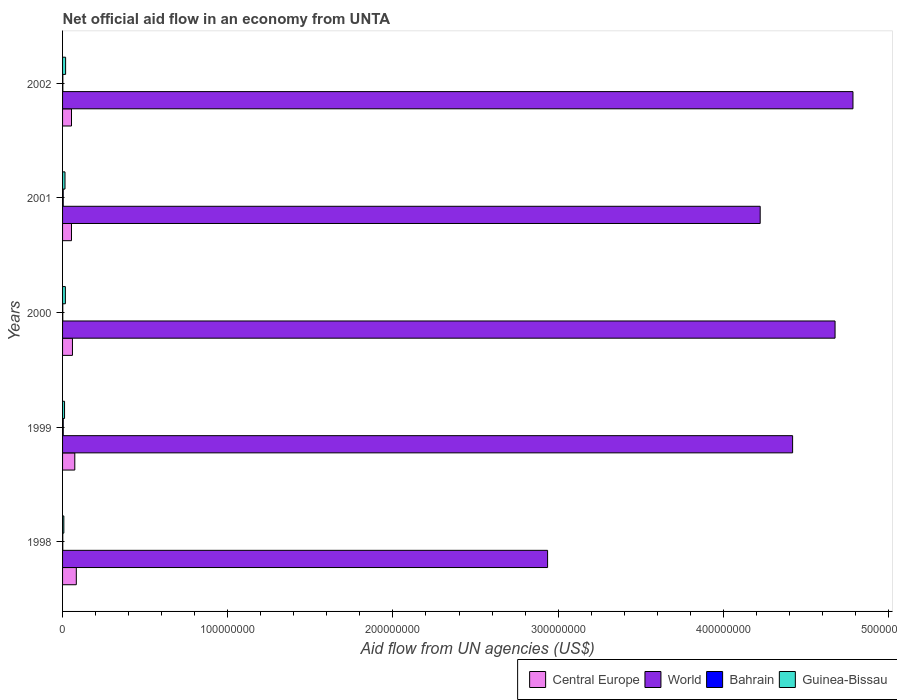How many groups of bars are there?
Provide a short and direct response. 5. Are the number of bars per tick equal to the number of legend labels?
Your answer should be compact. Yes. How many bars are there on the 1st tick from the top?
Provide a succinct answer. 4. What is the label of the 5th group of bars from the top?
Offer a terse response. 1998. What is the net official aid flow in Guinea-Bissau in 1998?
Your answer should be compact. 7.70e+05. Across all years, what is the maximum net official aid flow in Bahrain?
Ensure brevity in your answer.  4.00e+05. Across all years, what is the minimum net official aid flow in Central Europe?
Your answer should be compact. 5.40e+06. In which year was the net official aid flow in World maximum?
Offer a terse response. 2002. In which year was the net official aid flow in Guinea-Bissau minimum?
Offer a very short reply. 1998. What is the total net official aid flow in Guinea-Bissau in the graph?
Offer a terse response. 6.98e+06. What is the difference between the net official aid flow in Central Europe in 1998 and that in 1999?
Keep it short and to the point. 9.20e+05. What is the difference between the net official aid flow in Guinea-Bissau in 1999 and the net official aid flow in World in 2002?
Provide a short and direct response. -4.77e+08. What is the average net official aid flow in World per year?
Give a very brief answer. 4.21e+08. In the year 2002, what is the difference between the net official aid flow in World and net official aid flow in Bahrain?
Offer a terse response. 4.78e+08. What is the ratio of the net official aid flow in World in 1999 to that in 2000?
Your answer should be very brief. 0.95. Is the net official aid flow in Central Europe in 1999 less than that in 2002?
Your response must be concise. No. What is the difference between the highest and the second highest net official aid flow in Central Europe?
Ensure brevity in your answer.  9.20e+05. What is the difference between the highest and the lowest net official aid flow in Central Europe?
Make the answer very short. 2.92e+06. What does the 2nd bar from the top in 2001 represents?
Provide a succinct answer. Bahrain. How many bars are there?
Offer a terse response. 20. Are all the bars in the graph horizontal?
Make the answer very short. Yes. What is the difference between two consecutive major ticks on the X-axis?
Make the answer very short. 1.00e+08. How many legend labels are there?
Provide a succinct answer. 4. How are the legend labels stacked?
Make the answer very short. Horizontal. What is the title of the graph?
Provide a short and direct response. Net official aid flow in an economy from UNTA. What is the label or title of the X-axis?
Give a very brief answer. Aid flow from UN agencies (US$). What is the Aid flow from UN agencies (US$) of Central Europe in 1998?
Ensure brevity in your answer.  8.32e+06. What is the Aid flow from UN agencies (US$) of World in 1998?
Make the answer very short. 2.94e+08. What is the Aid flow from UN agencies (US$) in Bahrain in 1998?
Your answer should be very brief. 1.30e+05. What is the Aid flow from UN agencies (US$) in Guinea-Bissau in 1998?
Keep it short and to the point. 7.70e+05. What is the Aid flow from UN agencies (US$) of Central Europe in 1999?
Your answer should be very brief. 7.40e+06. What is the Aid flow from UN agencies (US$) in World in 1999?
Your answer should be very brief. 4.42e+08. What is the Aid flow from UN agencies (US$) of Guinea-Bissau in 1999?
Give a very brief answer. 1.20e+06. What is the Aid flow from UN agencies (US$) of Central Europe in 2000?
Make the answer very short. 5.99e+06. What is the Aid flow from UN agencies (US$) in World in 2000?
Give a very brief answer. 4.68e+08. What is the Aid flow from UN agencies (US$) of Guinea-Bissau in 2000?
Your answer should be compact. 1.70e+06. What is the Aid flow from UN agencies (US$) in Central Europe in 2001?
Offer a terse response. 5.40e+06. What is the Aid flow from UN agencies (US$) in World in 2001?
Give a very brief answer. 4.22e+08. What is the Aid flow from UN agencies (US$) of Bahrain in 2001?
Provide a short and direct response. 3.90e+05. What is the Aid flow from UN agencies (US$) in Guinea-Bissau in 2001?
Keep it short and to the point. 1.47e+06. What is the Aid flow from UN agencies (US$) of Central Europe in 2002?
Offer a very short reply. 5.41e+06. What is the Aid flow from UN agencies (US$) of World in 2002?
Keep it short and to the point. 4.78e+08. What is the Aid flow from UN agencies (US$) in Guinea-Bissau in 2002?
Your answer should be compact. 1.84e+06. Across all years, what is the maximum Aid flow from UN agencies (US$) in Central Europe?
Make the answer very short. 8.32e+06. Across all years, what is the maximum Aid flow from UN agencies (US$) in World?
Make the answer very short. 4.78e+08. Across all years, what is the maximum Aid flow from UN agencies (US$) of Guinea-Bissau?
Make the answer very short. 1.84e+06. Across all years, what is the minimum Aid flow from UN agencies (US$) in Central Europe?
Ensure brevity in your answer.  5.40e+06. Across all years, what is the minimum Aid flow from UN agencies (US$) in World?
Keep it short and to the point. 2.94e+08. Across all years, what is the minimum Aid flow from UN agencies (US$) in Guinea-Bissau?
Ensure brevity in your answer.  7.70e+05. What is the total Aid flow from UN agencies (US$) in Central Europe in the graph?
Provide a short and direct response. 3.25e+07. What is the total Aid flow from UN agencies (US$) in World in the graph?
Offer a terse response. 2.10e+09. What is the total Aid flow from UN agencies (US$) in Bahrain in the graph?
Your answer should be compact. 1.22e+06. What is the total Aid flow from UN agencies (US$) in Guinea-Bissau in the graph?
Your answer should be compact. 6.98e+06. What is the difference between the Aid flow from UN agencies (US$) in Central Europe in 1998 and that in 1999?
Offer a terse response. 9.20e+05. What is the difference between the Aid flow from UN agencies (US$) of World in 1998 and that in 1999?
Your answer should be compact. -1.48e+08. What is the difference between the Aid flow from UN agencies (US$) of Guinea-Bissau in 1998 and that in 1999?
Your answer should be compact. -4.30e+05. What is the difference between the Aid flow from UN agencies (US$) in Central Europe in 1998 and that in 2000?
Offer a terse response. 2.33e+06. What is the difference between the Aid flow from UN agencies (US$) of World in 1998 and that in 2000?
Ensure brevity in your answer.  -1.74e+08. What is the difference between the Aid flow from UN agencies (US$) of Guinea-Bissau in 1998 and that in 2000?
Make the answer very short. -9.30e+05. What is the difference between the Aid flow from UN agencies (US$) in Central Europe in 1998 and that in 2001?
Keep it short and to the point. 2.92e+06. What is the difference between the Aid flow from UN agencies (US$) in World in 1998 and that in 2001?
Offer a terse response. -1.29e+08. What is the difference between the Aid flow from UN agencies (US$) of Bahrain in 1998 and that in 2001?
Offer a very short reply. -2.60e+05. What is the difference between the Aid flow from UN agencies (US$) in Guinea-Bissau in 1998 and that in 2001?
Offer a terse response. -7.00e+05. What is the difference between the Aid flow from UN agencies (US$) in Central Europe in 1998 and that in 2002?
Provide a succinct answer. 2.91e+06. What is the difference between the Aid flow from UN agencies (US$) in World in 1998 and that in 2002?
Your response must be concise. -1.85e+08. What is the difference between the Aid flow from UN agencies (US$) of Guinea-Bissau in 1998 and that in 2002?
Ensure brevity in your answer.  -1.07e+06. What is the difference between the Aid flow from UN agencies (US$) in Central Europe in 1999 and that in 2000?
Offer a very short reply. 1.41e+06. What is the difference between the Aid flow from UN agencies (US$) of World in 1999 and that in 2000?
Make the answer very short. -2.57e+07. What is the difference between the Aid flow from UN agencies (US$) of Bahrain in 1999 and that in 2000?
Your response must be concise. 2.70e+05. What is the difference between the Aid flow from UN agencies (US$) of Guinea-Bissau in 1999 and that in 2000?
Provide a short and direct response. -5.00e+05. What is the difference between the Aid flow from UN agencies (US$) of Central Europe in 1999 and that in 2001?
Your response must be concise. 2.00e+06. What is the difference between the Aid flow from UN agencies (US$) in World in 1999 and that in 2001?
Your answer should be compact. 1.96e+07. What is the difference between the Aid flow from UN agencies (US$) in Bahrain in 1999 and that in 2001?
Offer a terse response. 10000. What is the difference between the Aid flow from UN agencies (US$) in Guinea-Bissau in 1999 and that in 2001?
Ensure brevity in your answer.  -2.70e+05. What is the difference between the Aid flow from UN agencies (US$) in Central Europe in 1999 and that in 2002?
Your answer should be compact. 1.99e+06. What is the difference between the Aid flow from UN agencies (US$) in World in 1999 and that in 2002?
Offer a very short reply. -3.65e+07. What is the difference between the Aid flow from UN agencies (US$) of Guinea-Bissau in 1999 and that in 2002?
Give a very brief answer. -6.40e+05. What is the difference between the Aid flow from UN agencies (US$) in Central Europe in 2000 and that in 2001?
Offer a very short reply. 5.90e+05. What is the difference between the Aid flow from UN agencies (US$) in World in 2000 and that in 2001?
Offer a very short reply. 4.53e+07. What is the difference between the Aid flow from UN agencies (US$) of Bahrain in 2000 and that in 2001?
Your response must be concise. -2.60e+05. What is the difference between the Aid flow from UN agencies (US$) in Guinea-Bissau in 2000 and that in 2001?
Give a very brief answer. 2.30e+05. What is the difference between the Aid flow from UN agencies (US$) in Central Europe in 2000 and that in 2002?
Offer a terse response. 5.80e+05. What is the difference between the Aid flow from UN agencies (US$) of World in 2000 and that in 2002?
Offer a terse response. -1.08e+07. What is the difference between the Aid flow from UN agencies (US$) in Bahrain in 2000 and that in 2002?
Provide a succinct answer. -4.00e+04. What is the difference between the Aid flow from UN agencies (US$) of Central Europe in 2001 and that in 2002?
Keep it short and to the point. -10000. What is the difference between the Aid flow from UN agencies (US$) of World in 2001 and that in 2002?
Your answer should be very brief. -5.62e+07. What is the difference between the Aid flow from UN agencies (US$) in Bahrain in 2001 and that in 2002?
Give a very brief answer. 2.20e+05. What is the difference between the Aid flow from UN agencies (US$) of Guinea-Bissau in 2001 and that in 2002?
Give a very brief answer. -3.70e+05. What is the difference between the Aid flow from UN agencies (US$) in Central Europe in 1998 and the Aid flow from UN agencies (US$) in World in 1999?
Offer a very short reply. -4.34e+08. What is the difference between the Aid flow from UN agencies (US$) in Central Europe in 1998 and the Aid flow from UN agencies (US$) in Bahrain in 1999?
Provide a short and direct response. 7.92e+06. What is the difference between the Aid flow from UN agencies (US$) of Central Europe in 1998 and the Aid flow from UN agencies (US$) of Guinea-Bissau in 1999?
Your answer should be very brief. 7.12e+06. What is the difference between the Aid flow from UN agencies (US$) of World in 1998 and the Aid flow from UN agencies (US$) of Bahrain in 1999?
Offer a terse response. 2.93e+08. What is the difference between the Aid flow from UN agencies (US$) of World in 1998 and the Aid flow from UN agencies (US$) of Guinea-Bissau in 1999?
Ensure brevity in your answer.  2.92e+08. What is the difference between the Aid flow from UN agencies (US$) in Bahrain in 1998 and the Aid flow from UN agencies (US$) in Guinea-Bissau in 1999?
Offer a terse response. -1.07e+06. What is the difference between the Aid flow from UN agencies (US$) in Central Europe in 1998 and the Aid flow from UN agencies (US$) in World in 2000?
Offer a terse response. -4.59e+08. What is the difference between the Aid flow from UN agencies (US$) in Central Europe in 1998 and the Aid flow from UN agencies (US$) in Bahrain in 2000?
Ensure brevity in your answer.  8.19e+06. What is the difference between the Aid flow from UN agencies (US$) of Central Europe in 1998 and the Aid flow from UN agencies (US$) of Guinea-Bissau in 2000?
Your response must be concise. 6.62e+06. What is the difference between the Aid flow from UN agencies (US$) in World in 1998 and the Aid flow from UN agencies (US$) in Bahrain in 2000?
Your response must be concise. 2.93e+08. What is the difference between the Aid flow from UN agencies (US$) of World in 1998 and the Aid flow from UN agencies (US$) of Guinea-Bissau in 2000?
Ensure brevity in your answer.  2.92e+08. What is the difference between the Aid flow from UN agencies (US$) of Bahrain in 1998 and the Aid flow from UN agencies (US$) of Guinea-Bissau in 2000?
Give a very brief answer. -1.57e+06. What is the difference between the Aid flow from UN agencies (US$) in Central Europe in 1998 and the Aid flow from UN agencies (US$) in World in 2001?
Offer a very short reply. -4.14e+08. What is the difference between the Aid flow from UN agencies (US$) in Central Europe in 1998 and the Aid flow from UN agencies (US$) in Bahrain in 2001?
Ensure brevity in your answer.  7.93e+06. What is the difference between the Aid flow from UN agencies (US$) in Central Europe in 1998 and the Aid flow from UN agencies (US$) in Guinea-Bissau in 2001?
Keep it short and to the point. 6.85e+06. What is the difference between the Aid flow from UN agencies (US$) of World in 1998 and the Aid flow from UN agencies (US$) of Bahrain in 2001?
Keep it short and to the point. 2.93e+08. What is the difference between the Aid flow from UN agencies (US$) in World in 1998 and the Aid flow from UN agencies (US$) in Guinea-Bissau in 2001?
Your answer should be very brief. 2.92e+08. What is the difference between the Aid flow from UN agencies (US$) in Bahrain in 1998 and the Aid flow from UN agencies (US$) in Guinea-Bissau in 2001?
Make the answer very short. -1.34e+06. What is the difference between the Aid flow from UN agencies (US$) in Central Europe in 1998 and the Aid flow from UN agencies (US$) in World in 2002?
Provide a short and direct response. -4.70e+08. What is the difference between the Aid flow from UN agencies (US$) of Central Europe in 1998 and the Aid flow from UN agencies (US$) of Bahrain in 2002?
Make the answer very short. 8.15e+06. What is the difference between the Aid flow from UN agencies (US$) in Central Europe in 1998 and the Aid flow from UN agencies (US$) in Guinea-Bissau in 2002?
Provide a succinct answer. 6.48e+06. What is the difference between the Aid flow from UN agencies (US$) in World in 1998 and the Aid flow from UN agencies (US$) in Bahrain in 2002?
Offer a terse response. 2.93e+08. What is the difference between the Aid flow from UN agencies (US$) of World in 1998 and the Aid flow from UN agencies (US$) of Guinea-Bissau in 2002?
Provide a succinct answer. 2.92e+08. What is the difference between the Aid flow from UN agencies (US$) in Bahrain in 1998 and the Aid flow from UN agencies (US$) in Guinea-Bissau in 2002?
Offer a very short reply. -1.71e+06. What is the difference between the Aid flow from UN agencies (US$) in Central Europe in 1999 and the Aid flow from UN agencies (US$) in World in 2000?
Provide a succinct answer. -4.60e+08. What is the difference between the Aid flow from UN agencies (US$) in Central Europe in 1999 and the Aid flow from UN agencies (US$) in Bahrain in 2000?
Keep it short and to the point. 7.27e+06. What is the difference between the Aid flow from UN agencies (US$) of Central Europe in 1999 and the Aid flow from UN agencies (US$) of Guinea-Bissau in 2000?
Make the answer very short. 5.70e+06. What is the difference between the Aid flow from UN agencies (US$) of World in 1999 and the Aid flow from UN agencies (US$) of Bahrain in 2000?
Ensure brevity in your answer.  4.42e+08. What is the difference between the Aid flow from UN agencies (US$) of World in 1999 and the Aid flow from UN agencies (US$) of Guinea-Bissau in 2000?
Keep it short and to the point. 4.40e+08. What is the difference between the Aid flow from UN agencies (US$) of Bahrain in 1999 and the Aid flow from UN agencies (US$) of Guinea-Bissau in 2000?
Offer a very short reply. -1.30e+06. What is the difference between the Aid flow from UN agencies (US$) in Central Europe in 1999 and the Aid flow from UN agencies (US$) in World in 2001?
Make the answer very short. -4.15e+08. What is the difference between the Aid flow from UN agencies (US$) in Central Europe in 1999 and the Aid flow from UN agencies (US$) in Bahrain in 2001?
Give a very brief answer. 7.01e+06. What is the difference between the Aid flow from UN agencies (US$) of Central Europe in 1999 and the Aid flow from UN agencies (US$) of Guinea-Bissau in 2001?
Provide a short and direct response. 5.93e+06. What is the difference between the Aid flow from UN agencies (US$) of World in 1999 and the Aid flow from UN agencies (US$) of Bahrain in 2001?
Your response must be concise. 4.42e+08. What is the difference between the Aid flow from UN agencies (US$) of World in 1999 and the Aid flow from UN agencies (US$) of Guinea-Bissau in 2001?
Offer a terse response. 4.40e+08. What is the difference between the Aid flow from UN agencies (US$) in Bahrain in 1999 and the Aid flow from UN agencies (US$) in Guinea-Bissau in 2001?
Give a very brief answer. -1.07e+06. What is the difference between the Aid flow from UN agencies (US$) of Central Europe in 1999 and the Aid flow from UN agencies (US$) of World in 2002?
Offer a terse response. -4.71e+08. What is the difference between the Aid flow from UN agencies (US$) in Central Europe in 1999 and the Aid flow from UN agencies (US$) in Bahrain in 2002?
Give a very brief answer. 7.23e+06. What is the difference between the Aid flow from UN agencies (US$) in Central Europe in 1999 and the Aid flow from UN agencies (US$) in Guinea-Bissau in 2002?
Your answer should be very brief. 5.56e+06. What is the difference between the Aid flow from UN agencies (US$) of World in 1999 and the Aid flow from UN agencies (US$) of Bahrain in 2002?
Keep it short and to the point. 4.42e+08. What is the difference between the Aid flow from UN agencies (US$) of World in 1999 and the Aid flow from UN agencies (US$) of Guinea-Bissau in 2002?
Ensure brevity in your answer.  4.40e+08. What is the difference between the Aid flow from UN agencies (US$) in Bahrain in 1999 and the Aid flow from UN agencies (US$) in Guinea-Bissau in 2002?
Offer a terse response. -1.44e+06. What is the difference between the Aid flow from UN agencies (US$) of Central Europe in 2000 and the Aid flow from UN agencies (US$) of World in 2001?
Offer a very short reply. -4.16e+08. What is the difference between the Aid flow from UN agencies (US$) of Central Europe in 2000 and the Aid flow from UN agencies (US$) of Bahrain in 2001?
Offer a terse response. 5.60e+06. What is the difference between the Aid flow from UN agencies (US$) of Central Europe in 2000 and the Aid flow from UN agencies (US$) of Guinea-Bissau in 2001?
Ensure brevity in your answer.  4.52e+06. What is the difference between the Aid flow from UN agencies (US$) of World in 2000 and the Aid flow from UN agencies (US$) of Bahrain in 2001?
Give a very brief answer. 4.67e+08. What is the difference between the Aid flow from UN agencies (US$) in World in 2000 and the Aid flow from UN agencies (US$) in Guinea-Bissau in 2001?
Give a very brief answer. 4.66e+08. What is the difference between the Aid flow from UN agencies (US$) of Bahrain in 2000 and the Aid flow from UN agencies (US$) of Guinea-Bissau in 2001?
Offer a terse response. -1.34e+06. What is the difference between the Aid flow from UN agencies (US$) in Central Europe in 2000 and the Aid flow from UN agencies (US$) in World in 2002?
Offer a very short reply. -4.72e+08. What is the difference between the Aid flow from UN agencies (US$) of Central Europe in 2000 and the Aid flow from UN agencies (US$) of Bahrain in 2002?
Keep it short and to the point. 5.82e+06. What is the difference between the Aid flow from UN agencies (US$) in Central Europe in 2000 and the Aid flow from UN agencies (US$) in Guinea-Bissau in 2002?
Your response must be concise. 4.15e+06. What is the difference between the Aid flow from UN agencies (US$) in World in 2000 and the Aid flow from UN agencies (US$) in Bahrain in 2002?
Ensure brevity in your answer.  4.67e+08. What is the difference between the Aid flow from UN agencies (US$) in World in 2000 and the Aid flow from UN agencies (US$) in Guinea-Bissau in 2002?
Offer a terse response. 4.66e+08. What is the difference between the Aid flow from UN agencies (US$) of Bahrain in 2000 and the Aid flow from UN agencies (US$) of Guinea-Bissau in 2002?
Keep it short and to the point. -1.71e+06. What is the difference between the Aid flow from UN agencies (US$) of Central Europe in 2001 and the Aid flow from UN agencies (US$) of World in 2002?
Your answer should be very brief. -4.73e+08. What is the difference between the Aid flow from UN agencies (US$) of Central Europe in 2001 and the Aid flow from UN agencies (US$) of Bahrain in 2002?
Give a very brief answer. 5.23e+06. What is the difference between the Aid flow from UN agencies (US$) of Central Europe in 2001 and the Aid flow from UN agencies (US$) of Guinea-Bissau in 2002?
Make the answer very short. 3.56e+06. What is the difference between the Aid flow from UN agencies (US$) of World in 2001 and the Aid flow from UN agencies (US$) of Bahrain in 2002?
Offer a terse response. 4.22e+08. What is the difference between the Aid flow from UN agencies (US$) of World in 2001 and the Aid flow from UN agencies (US$) of Guinea-Bissau in 2002?
Your answer should be compact. 4.20e+08. What is the difference between the Aid flow from UN agencies (US$) of Bahrain in 2001 and the Aid flow from UN agencies (US$) of Guinea-Bissau in 2002?
Keep it short and to the point. -1.45e+06. What is the average Aid flow from UN agencies (US$) of Central Europe per year?
Offer a terse response. 6.50e+06. What is the average Aid flow from UN agencies (US$) of World per year?
Make the answer very short. 4.21e+08. What is the average Aid flow from UN agencies (US$) of Bahrain per year?
Make the answer very short. 2.44e+05. What is the average Aid flow from UN agencies (US$) in Guinea-Bissau per year?
Ensure brevity in your answer.  1.40e+06. In the year 1998, what is the difference between the Aid flow from UN agencies (US$) of Central Europe and Aid flow from UN agencies (US$) of World?
Your answer should be compact. -2.85e+08. In the year 1998, what is the difference between the Aid flow from UN agencies (US$) in Central Europe and Aid flow from UN agencies (US$) in Bahrain?
Offer a very short reply. 8.19e+06. In the year 1998, what is the difference between the Aid flow from UN agencies (US$) of Central Europe and Aid flow from UN agencies (US$) of Guinea-Bissau?
Offer a very short reply. 7.55e+06. In the year 1998, what is the difference between the Aid flow from UN agencies (US$) of World and Aid flow from UN agencies (US$) of Bahrain?
Keep it short and to the point. 2.93e+08. In the year 1998, what is the difference between the Aid flow from UN agencies (US$) in World and Aid flow from UN agencies (US$) in Guinea-Bissau?
Offer a very short reply. 2.93e+08. In the year 1998, what is the difference between the Aid flow from UN agencies (US$) of Bahrain and Aid flow from UN agencies (US$) of Guinea-Bissau?
Offer a very short reply. -6.40e+05. In the year 1999, what is the difference between the Aid flow from UN agencies (US$) in Central Europe and Aid flow from UN agencies (US$) in World?
Offer a terse response. -4.35e+08. In the year 1999, what is the difference between the Aid flow from UN agencies (US$) in Central Europe and Aid flow from UN agencies (US$) in Guinea-Bissau?
Your answer should be very brief. 6.20e+06. In the year 1999, what is the difference between the Aid flow from UN agencies (US$) in World and Aid flow from UN agencies (US$) in Bahrain?
Your answer should be very brief. 4.42e+08. In the year 1999, what is the difference between the Aid flow from UN agencies (US$) in World and Aid flow from UN agencies (US$) in Guinea-Bissau?
Ensure brevity in your answer.  4.41e+08. In the year 1999, what is the difference between the Aid flow from UN agencies (US$) in Bahrain and Aid flow from UN agencies (US$) in Guinea-Bissau?
Give a very brief answer. -8.00e+05. In the year 2000, what is the difference between the Aid flow from UN agencies (US$) of Central Europe and Aid flow from UN agencies (US$) of World?
Your answer should be compact. -4.62e+08. In the year 2000, what is the difference between the Aid flow from UN agencies (US$) in Central Europe and Aid flow from UN agencies (US$) in Bahrain?
Offer a terse response. 5.86e+06. In the year 2000, what is the difference between the Aid flow from UN agencies (US$) of Central Europe and Aid flow from UN agencies (US$) of Guinea-Bissau?
Provide a short and direct response. 4.29e+06. In the year 2000, what is the difference between the Aid flow from UN agencies (US$) in World and Aid flow from UN agencies (US$) in Bahrain?
Ensure brevity in your answer.  4.68e+08. In the year 2000, what is the difference between the Aid flow from UN agencies (US$) of World and Aid flow from UN agencies (US$) of Guinea-Bissau?
Keep it short and to the point. 4.66e+08. In the year 2000, what is the difference between the Aid flow from UN agencies (US$) of Bahrain and Aid flow from UN agencies (US$) of Guinea-Bissau?
Offer a very short reply. -1.57e+06. In the year 2001, what is the difference between the Aid flow from UN agencies (US$) of Central Europe and Aid flow from UN agencies (US$) of World?
Provide a short and direct response. -4.17e+08. In the year 2001, what is the difference between the Aid flow from UN agencies (US$) in Central Europe and Aid flow from UN agencies (US$) in Bahrain?
Make the answer very short. 5.01e+06. In the year 2001, what is the difference between the Aid flow from UN agencies (US$) in Central Europe and Aid flow from UN agencies (US$) in Guinea-Bissau?
Offer a terse response. 3.93e+06. In the year 2001, what is the difference between the Aid flow from UN agencies (US$) in World and Aid flow from UN agencies (US$) in Bahrain?
Offer a very short reply. 4.22e+08. In the year 2001, what is the difference between the Aid flow from UN agencies (US$) in World and Aid flow from UN agencies (US$) in Guinea-Bissau?
Your response must be concise. 4.21e+08. In the year 2001, what is the difference between the Aid flow from UN agencies (US$) of Bahrain and Aid flow from UN agencies (US$) of Guinea-Bissau?
Your answer should be compact. -1.08e+06. In the year 2002, what is the difference between the Aid flow from UN agencies (US$) in Central Europe and Aid flow from UN agencies (US$) in World?
Offer a very short reply. -4.73e+08. In the year 2002, what is the difference between the Aid flow from UN agencies (US$) in Central Europe and Aid flow from UN agencies (US$) in Bahrain?
Your answer should be compact. 5.24e+06. In the year 2002, what is the difference between the Aid flow from UN agencies (US$) of Central Europe and Aid flow from UN agencies (US$) of Guinea-Bissau?
Keep it short and to the point. 3.57e+06. In the year 2002, what is the difference between the Aid flow from UN agencies (US$) in World and Aid flow from UN agencies (US$) in Bahrain?
Your response must be concise. 4.78e+08. In the year 2002, what is the difference between the Aid flow from UN agencies (US$) of World and Aid flow from UN agencies (US$) of Guinea-Bissau?
Give a very brief answer. 4.77e+08. In the year 2002, what is the difference between the Aid flow from UN agencies (US$) of Bahrain and Aid flow from UN agencies (US$) of Guinea-Bissau?
Offer a terse response. -1.67e+06. What is the ratio of the Aid flow from UN agencies (US$) in Central Europe in 1998 to that in 1999?
Give a very brief answer. 1.12. What is the ratio of the Aid flow from UN agencies (US$) in World in 1998 to that in 1999?
Your answer should be compact. 0.66. What is the ratio of the Aid flow from UN agencies (US$) of Bahrain in 1998 to that in 1999?
Make the answer very short. 0.33. What is the ratio of the Aid flow from UN agencies (US$) in Guinea-Bissau in 1998 to that in 1999?
Your response must be concise. 0.64. What is the ratio of the Aid flow from UN agencies (US$) of Central Europe in 1998 to that in 2000?
Your response must be concise. 1.39. What is the ratio of the Aid flow from UN agencies (US$) in World in 1998 to that in 2000?
Give a very brief answer. 0.63. What is the ratio of the Aid flow from UN agencies (US$) in Guinea-Bissau in 1998 to that in 2000?
Your response must be concise. 0.45. What is the ratio of the Aid flow from UN agencies (US$) in Central Europe in 1998 to that in 2001?
Make the answer very short. 1.54. What is the ratio of the Aid flow from UN agencies (US$) in World in 1998 to that in 2001?
Your answer should be compact. 0.7. What is the ratio of the Aid flow from UN agencies (US$) of Guinea-Bissau in 1998 to that in 2001?
Your answer should be very brief. 0.52. What is the ratio of the Aid flow from UN agencies (US$) in Central Europe in 1998 to that in 2002?
Offer a terse response. 1.54. What is the ratio of the Aid flow from UN agencies (US$) in World in 1998 to that in 2002?
Make the answer very short. 0.61. What is the ratio of the Aid flow from UN agencies (US$) in Bahrain in 1998 to that in 2002?
Your answer should be compact. 0.76. What is the ratio of the Aid flow from UN agencies (US$) in Guinea-Bissau in 1998 to that in 2002?
Offer a terse response. 0.42. What is the ratio of the Aid flow from UN agencies (US$) of Central Europe in 1999 to that in 2000?
Offer a very short reply. 1.24. What is the ratio of the Aid flow from UN agencies (US$) of World in 1999 to that in 2000?
Your response must be concise. 0.94. What is the ratio of the Aid flow from UN agencies (US$) of Bahrain in 1999 to that in 2000?
Provide a short and direct response. 3.08. What is the ratio of the Aid flow from UN agencies (US$) of Guinea-Bissau in 1999 to that in 2000?
Provide a short and direct response. 0.71. What is the ratio of the Aid flow from UN agencies (US$) in Central Europe in 1999 to that in 2001?
Offer a terse response. 1.37. What is the ratio of the Aid flow from UN agencies (US$) of World in 1999 to that in 2001?
Your answer should be very brief. 1.05. What is the ratio of the Aid flow from UN agencies (US$) in Bahrain in 1999 to that in 2001?
Your answer should be very brief. 1.03. What is the ratio of the Aid flow from UN agencies (US$) in Guinea-Bissau in 1999 to that in 2001?
Give a very brief answer. 0.82. What is the ratio of the Aid flow from UN agencies (US$) in Central Europe in 1999 to that in 2002?
Make the answer very short. 1.37. What is the ratio of the Aid flow from UN agencies (US$) in World in 1999 to that in 2002?
Make the answer very short. 0.92. What is the ratio of the Aid flow from UN agencies (US$) in Bahrain in 1999 to that in 2002?
Give a very brief answer. 2.35. What is the ratio of the Aid flow from UN agencies (US$) in Guinea-Bissau in 1999 to that in 2002?
Make the answer very short. 0.65. What is the ratio of the Aid flow from UN agencies (US$) of Central Europe in 2000 to that in 2001?
Offer a very short reply. 1.11. What is the ratio of the Aid flow from UN agencies (US$) in World in 2000 to that in 2001?
Provide a succinct answer. 1.11. What is the ratio of the Aid flow from UN agencies (US$) of Bahrain in 2000 to that in 2001?
Give a very brief answer. 0.33. What is the ratio of the Aid flow from UN agencies (US$) in Guinea-Bissau in 2000 to that in 2001?
Your answer should be very brief. 1.16. What is the ratio of the Aid flow from UN agencies (US$) of Central Europe in 2000 to that in 2002?
Provide a succinct answer. 1.11. What is the ratio of the Aid flow from UN agencies (US$) in World in 2000 to that in 2002?
Your answer should be very brief. 0.98. What is the ratio of the Aid flow from UN agencies (US$) in Bahrain in 2000 to that in 2002?
Keep it short and to the point. 0.76. What is the ratio of the Aid flow from UN agencies (US$) in Guinea-Bissau in 2000 to that in 2002?
Offer a terse response. 0.92. What is the ratio of the Aid flow from UN agencies (US$) in World in 2001 to that in 2002?
Your response must be concise. 0.88. What is the ratio of the Aid flow from UN agencies (US$) in Bahrain in 2001 to that in 2002?
Offer a very short reply. 2.29. What is the ratio of the Aid flow from UN agencies (US$) of Guinea-Bissau in 2001 to that in 2002?
Provide a succinct answer. 0.8. What is the difference between the highest and the second highest Aid flow from UN agencies (US$) of Central Europe?
Offer a terse response. 9.20e+05. What is the difference between the highest and the second highest Aid flow from UN agencies (US$) of World?
Provide a short and direct response. 1.08e+07. What is the difference between the highest and the second highest Aid flow from UN agencies (US$) in Guinea-Bissau?
Ensure brevity in your answer.  1.40e+05. What is the difference between the highest and the lowest Aid flow from UN agencies (US$) in Central Europe?
Provide a succinct answer. 2.92e+06. What is the difference between the highest and the lowest Aid flow from UN agencies (US$) of World?
Provide a short and direct response. 1.85e+08. What is the difference between the highest and the lowest Aid flow from UN agencies (US$) in Guinea-Bissau?
Offer a terse response. 1.07e+06. 